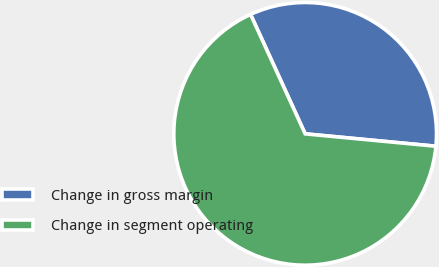<chart> <loc_0><loc_0><loc_500><loc_500><pie_chart><fcel>Change in gross margin<fcel>Change in segment operating<nl><fcel>33.33%<fcel>66.67%<nl></chart> 